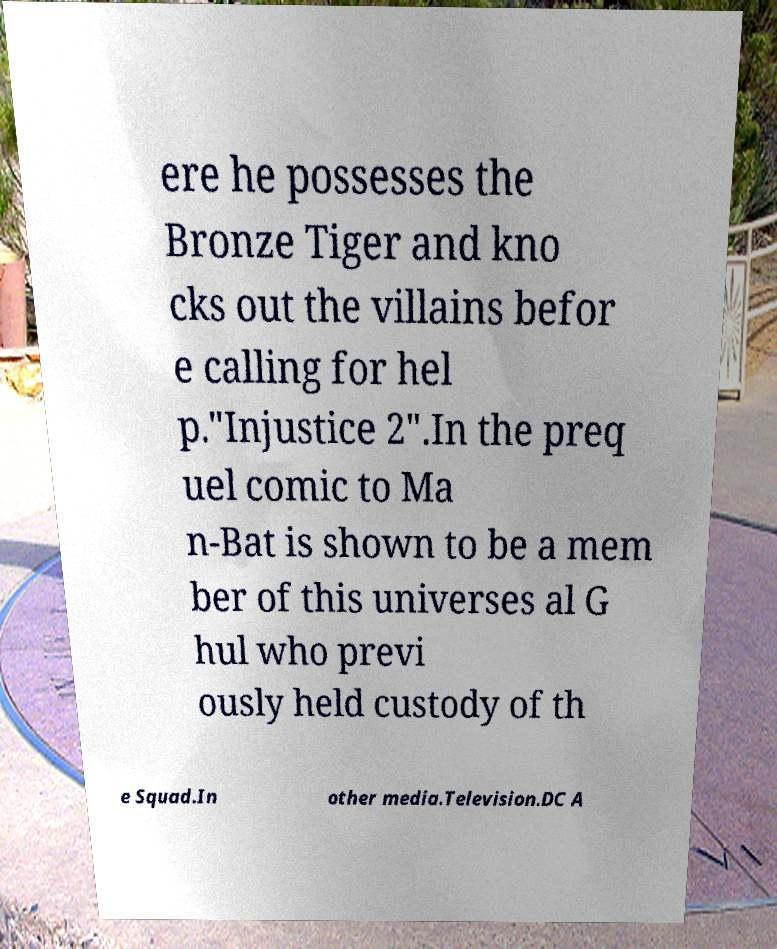Please read and relay the text visible in this image. What does it say? ere he possesses the Bronze Tiger and kno cks out the villains befor e calling for hel p."Injustice 2".In the preq uel comic to Ma n-Bat is shown to be a mem ber of this universes al G hul who previ ously held custody of th e Squad.In other media.Television.DC A 